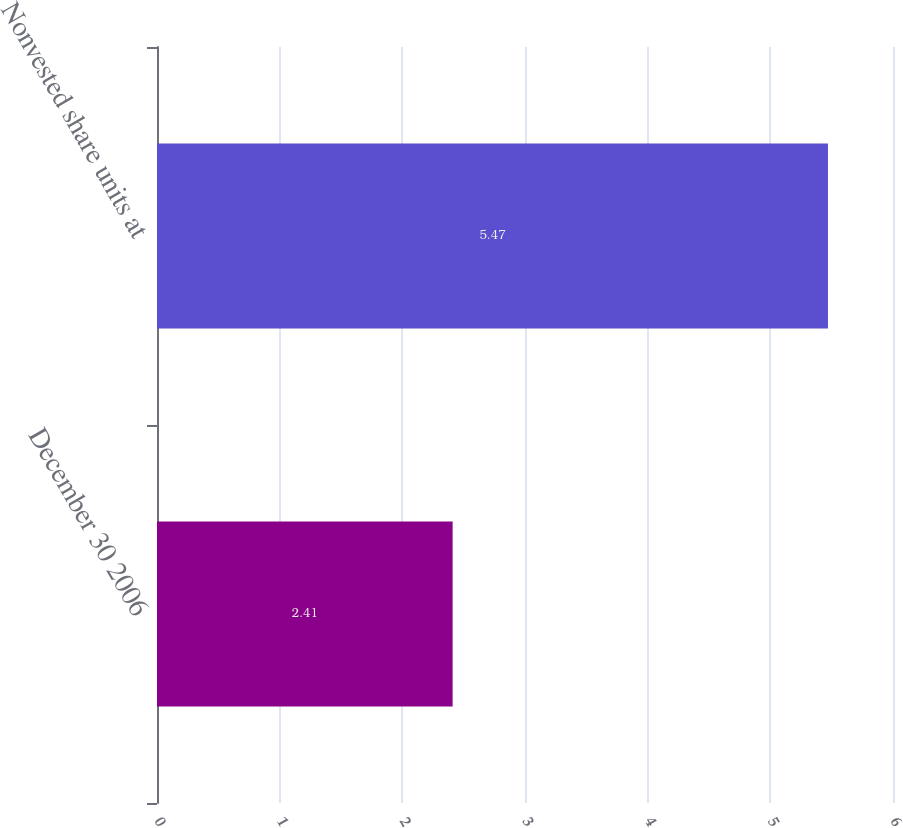Convert chart to OTSL. <chart><loc_0><loc_0><loc_500><loc_500><bar_chart><fcel>December 30 2006<fcel>Nonvested share units at<nl><fcel>2.41<fcel>5.47<nl></chart> 